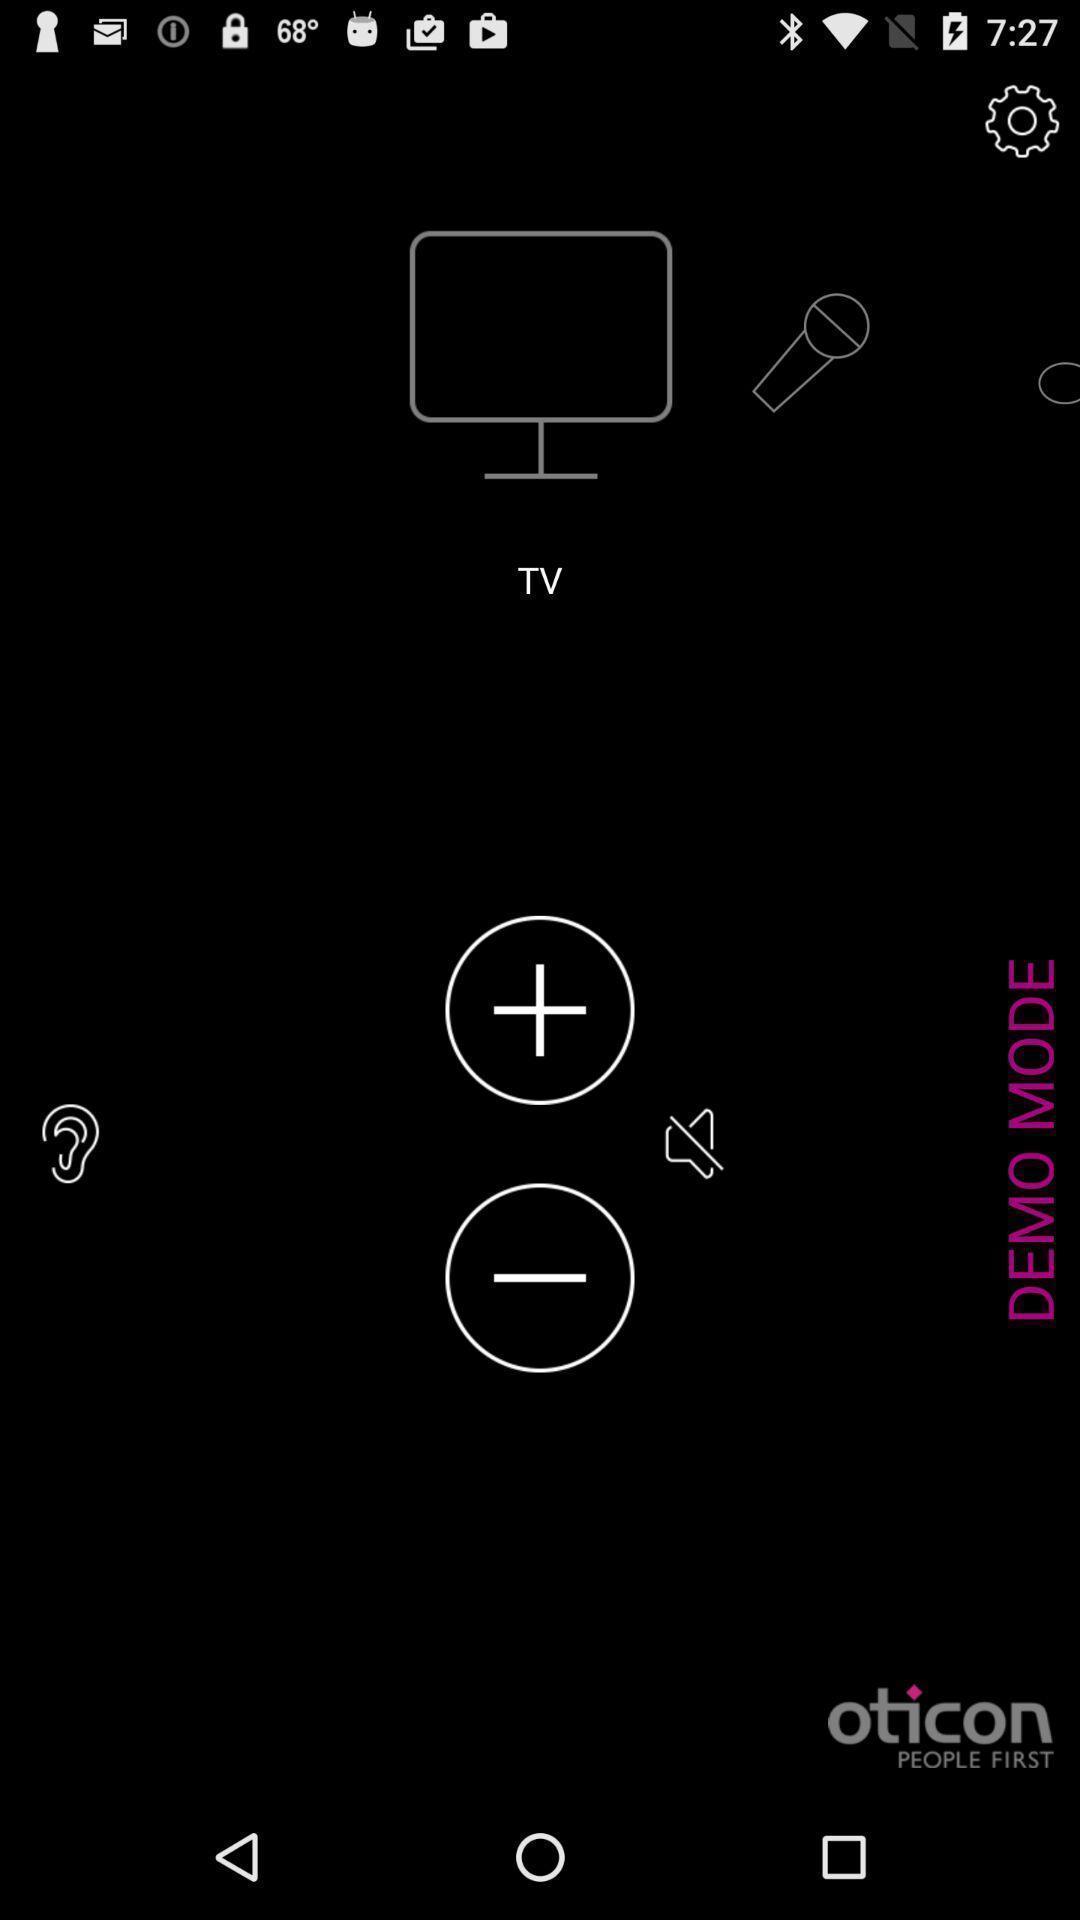Tell me about the visual elements in this screen capture. Page showing television control options. 